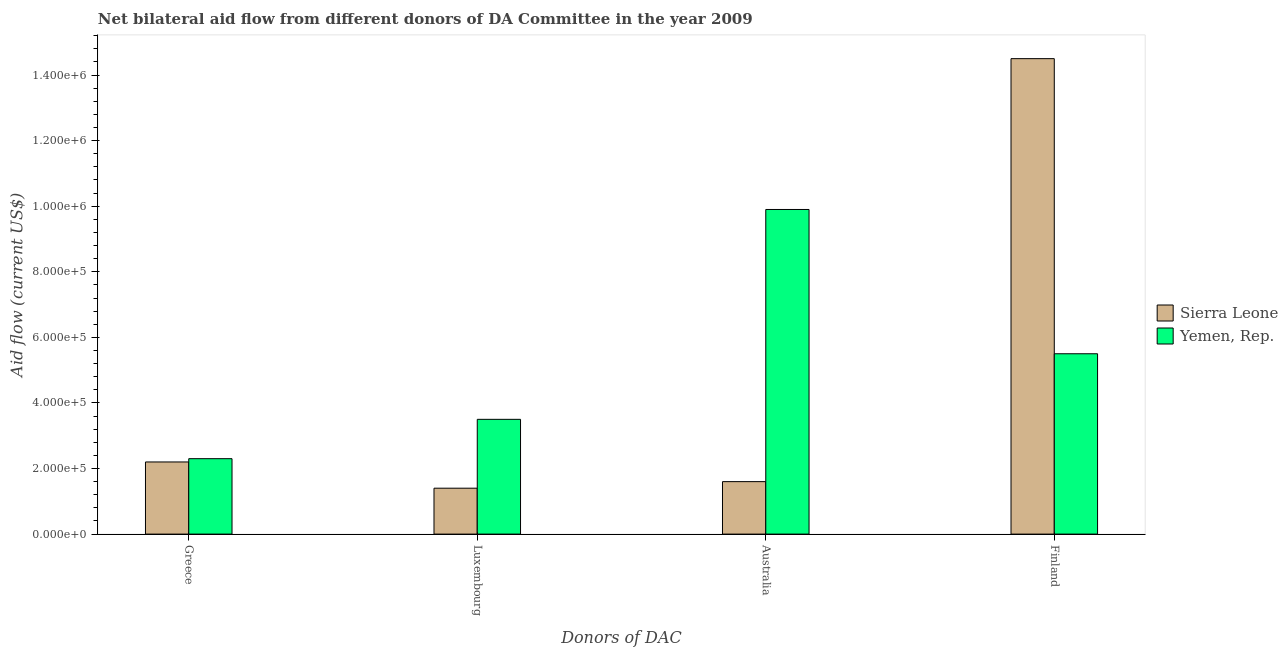How many different coloured bars are there?
Offer a terse response. 2. Are the number of bars per tick equal to the number of legend labels?
Make the answer very short. Yes. Are the number of bars on each tick of the X-axis equal?
Your response must be concise. Yes. How many bars are there on the 3rd tick from the left?
Your answer should be very brief. 2. How many bars are there on the 1st tick from the right?
Give a very brief answer. 2. What is the label of the 4th group of bars from the left?
Offer a very short reply. Finland. What is the amount of aid given by luxembourg in Yemen, Rep.?
Provide a short and direct response. 3.50e+05. Across all countries, what is the maximum amount of aid given by australia?
Provide a short and direct response. 9.90e+05. Across all countries, what is the minimum amount of aid given by luxembourg?
Offer a terse response. 1.40e+05. In which country was the amount of aid given by greece maximum?
Offer a very short reply. Yemen, Rep. In which country was the amount of aid given by finland minimum?
Your answer should be very brief. Yemen, Rep. What is the total amount of aid given by greece in the graph?
Your answer should be compact. 4.50e+05. What is the difference between the amount of aid given by finland in Sierra Leone and that in Yemen, Rep.?
Your answer should be very brief. 9.00e+05. What is the difference between the amount of aid given by greece in Yemen, Rep. and the amount of aid given by australia in Sierra Leone?
Your answer should be very brief. 7.00e+04. What is the average amount of aid given by greece per country?
Offer a terse response. 2.25e+05. What is the difference between the amount of aid given by luxembourg and amount of aid given by finland in Yemen, Rep.?
Provide a succinct answer. -2.00e+05. In how many countries, is the amount of aid given by luxembourg greater than 800000 US$?
Your answer should be compact. 0. What is the ratio of the amount of aid given by finland in Sierra Leone to that in Yemen, Rep.?
Your answer should be very brief. 2.64. What is the difference between the highest and the second highest amount of aid given by finland?
Provide a short and direct response. 9.00e+05. What is the difference between the highest and the lowest amount of aid given by australia?
Make the answer very short. 8.30e+05. Is the sum of the amount of aid given by finland in Sierra Leone and Yemen, Rep. greater than the maximum amount of aid given by greece across all countries?
Give a very brief answer. Yes. Is it the case that in every country, the sum of the amount of aid given by finland and amount of aid given by australia is greater than the sum of amount of aid given by greece and amount of aid given by luxembourg?
Make the answer very short. No. What does the 1st bar from the left in Finland represents?
Offer a terse response. Sierra Leone. What does the 1st bar from the right in Finland represents?
Your answer should be compact. Yemen, Rep. Is it the case that in every country, the sum of the amount of aid given by greece and amount of aid given by luxembourg is greater than the amount of aid given by australia?
Your response must be concise. No. Are all the bars in the graph horizontal?
Make the answer very short. No. Are the values on the major ticks of Y-axis written in scientific E-notation?
Provide a short and direct response. Yes. Does the graph contain any zero values?
Your answer should be very brief. No. Does the graph contain grids?
Your answer should be compact. No. How many legend labels are there?
Your response must be concise. 2. How are the legend labels stacked?
Give a very brief answer. Vertical. What is the title of the graph?
Keep it short and to the point. Net bilateral aid flow from different donors of DA Committee in the year 2009. Does "Dominican Republic" appear as one of the legend labels in the graph?
Offer a very short reply. No. What is the label or title of the X-axis?
Provide a short and direct response. Donors of DAC. What is the Aid flow (current US$) of Sierra Leone in Luxembourg?
Keep it short and to the point. 1.40e+05. What is the Aid flow (current US$) of Yemen, Rep. in Luxembourg?
Provide a succinct answer. 3.50e+05. What is the Aid flow (current US$) of Sierra Leone in Australia?
Make the answer very short. 1.60e+05. What is the Aid flow (current US$) of Yemen, Rep. in Australia?
Your response must be concise. 9.90e+05. What is the Aid flow (current US$) in Sierra Leone in Finland?
Your answer should be compact. 1.45e+06. Across all Donors of DAC, what is the maximum Aid flow (current US$) in Sierra Leone?
Give a very brief answer. 1.45e+06. Across all Donors of DAC, what is the maximum Aid flow (current US$) in Yemen, Rep.?
Your response must be concise. 9.90e+05. Across all Donors of DAC, what is the minimum Aid flow (current US$) of Yemen, Rep.?
Keep it short and to the point. 2.30e+05. What is the total Aid flow (current US$) in Sierra Leone in the graph?
Ensure brevity in your answer.  1.97e+06. What is the total Aid flow (current US$) of Yemen, Rep. in the graph?
Offer a very short reply. 2.12e+06. What is the difference between the Aid flow (current US$) in Yemen, Rep. in Greece and that in Luxembourg?
Offer a very short reply. -1.20e+05. What is the difference between the Aid flow (current US$) in Sierra Leone in Greece and that in Australia?
Your response must be concise. 6.00e+04. What is the difference between the Aid flow (current US$) in Yemen, Rep. in Greece and that in Australia?
Offer a terse response. -7.60e+05. What is the difference between the Aid flow (current US$) of Sierra Leone in Greece and that in Finland?
Ensure brevity in your answer.  -1.23e+06. What is the difference between the Aid flow (current US$) of Yemen, Rep. in Greece and that in Finland?
Provide a succinct answer. -3.20e+05. What is the difference between the Aid flow (current US$) of Yemen, Rep. in Luxembourg and that in Australia?
Offer a terse response. -6.40e+05. What is the difference between the Aid flow (current US$) of Sierra Leone in Luxembourg and that in Finland?
Provide a succinct answer. -1.31e+06. What is the difference between the Aid flow (current US$) of Yemen, Rep. in Luxembourg and that in Finland?
Provide a succinct answer. -2.00e+05. What is the difference between the Aid flow (current US$) in Sierra Leone in Australia and that in Finland?
Make the answer very short. -1.29e+06. What is the difference between the Aid flow (current US$) of Sierra Leone in Greece and the Aid flow (current US$) of Yemen, Rep. in Australia?
Your answer should be very brief. -7.70e+05. What is the difference between the Aid flow (current US$) of Sierra Leone in Greece and the Aid flow (current US$) of Yemen, Rep. in Finland?
Your response must be concise. -3.30e+05. What is the difference between the Aid flow (current US$) of Sierra Leone in Luxembourg and the Aid flow (current US$) of Yemen, Rep. in Australia?
Provide a succinct answer. -8.50e+05. What is the difference between the Aid flow (current US$) in Sierra Leone in Luxembourg and the Aid flow (current US$) in Yemen, Rep. in Finland?
Your response must be concise. -4.10e+05. What is the difference between the Aid flow (current US$) in Sierra Leone in Australia and the Aid flow (current US$) in Yemen, Rep. in Finland?
Provide a succinct answer. -3.90e+05. What is the average Aid flow (current US$) of Sierra Leone per Donors of DAC?
Offer a terse response. 4.92e+05. What is the average Aid flow (current US$) in Yemen, Rep. per Donors of DAC?
Your answer should be compact. 5.30e+05. What is the difference between the Aid flow (current US$) of Sierra Leone and Aid flow (current US$) of Yemen, Rep. in Greece?
Your answer should be very brief. -10000. What is the difference between the Aid flow (current US$) in Sierra Leone and Aid flow (current US$) in Yemen, Rep. in Australia?
Make the answer very short. -8.30e+05. What is the difference between the Aid flow (current US$) of Sierra Leone and Aid flow (current US$) of Yemen, Rep. in Finland?
Provide a short and direct response. 9.00e+05. What is the ratio of the Aid flow (current US$) of Sierra Leone in Greece to that in Luxembourg?
Offer a very short reply. 1.57. What is the ratio of the Aid flow (current US$) in Yemen, Rep. in Greece to that in Luxembourg?
Offer a terse response. 0.66. What is the ratio of the Aid flow (current US$) in Sierra Leone in Greece to that in Australia?
Keep it short and to the point. 1.38. What is the ratio of the Aid flow (current US$) of Yemen, Rep. in Greece to that in Australia?
Give a very brief answer. 0.23. What is the ratio of the Aid flow (current US$) in Sierra Leone in Greece to that in Finland?
Provide a succinct answer. 0.15. What is the ratio of the Aid flow (current US$) of Yemen, Rep. in Greece to that in Finland?
Provide a short and direct response. 0.42. What is the ratio of the Aid flow (current US$) of Yemen, Rep. in Luxembourg to that in Australia?
Provide a succinct answer. 0.35. What is the ratio of the Aid flow (current US$) in Sierra Leone in Luxembourg to that in Finland?
Your answer should be compact. 0.1. What is the ratio of the Aid flow (current US$) in Yemen, Rep. in Luxembourg to that in Finland?
Ensure brevity in your answer.  0.64. What is the ratio of the Aid flow (current US$) in Sierra Leone in Australia to that in Finland?
Offer a terse response. 0.11. What is the ratio of the Aid flow (current US$) of Yemen, Rep. in Australia to that in Finland?
Provide a succinct answer. 1.8. What is the difference between the highest and the second highest Aid flow (current US$) in Sierra Leone?
Your answer should be compact. 1.23e+06. What is the difference between the highest and the lowest Aid flow (current US$) in Sierra Leone?
Ensure brevity in your answer.  1.31e+06. What is the difference between the highest and the lowest Aid flow (current US$) of Yemen, Rep.?
Give a very brief answer. 7.60e+05. 